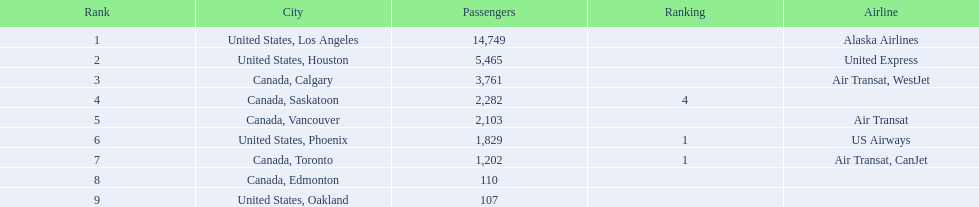What was the number of passengers in phoenix arizona? 1,829. 